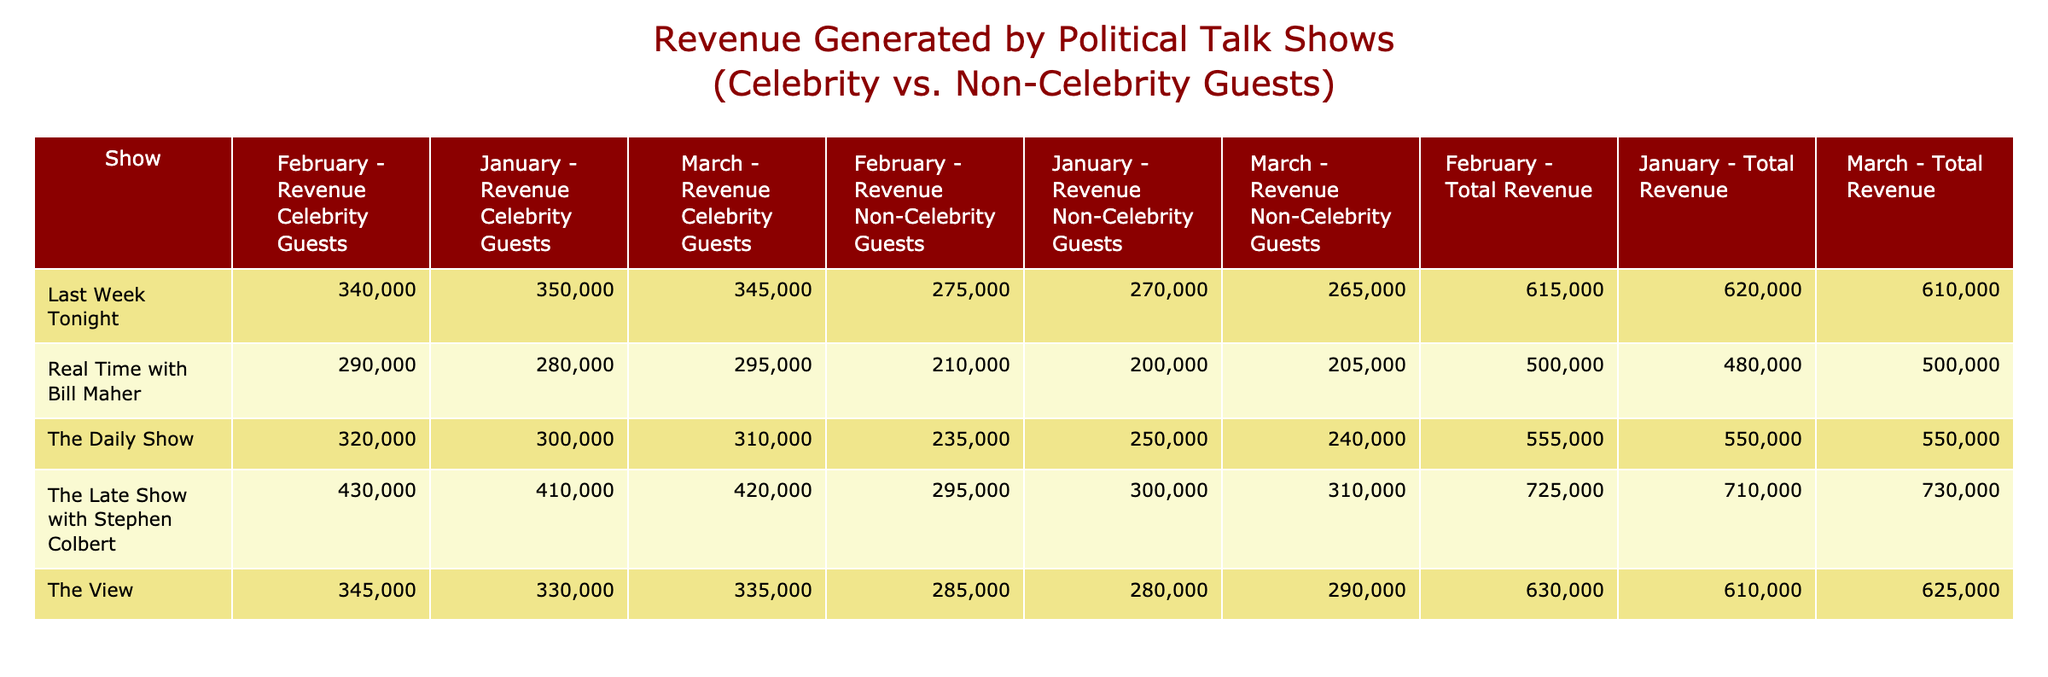What was the total revenue for The Late Show with Stephen Colbert in February? The revenue for The Late Show with Stephen Colbert in February from celebrity guests was 430,000, and from non-celebrity guests was 295,000. Adding these two amounts (430,000 + 295,000) gives us a total of 725,000.
Answer: 725000 Which show had the highest revenue from non-celebrity guests in January? In January, the non-celebrity revenue for each show was as follows: The Daily Show 250,000, Real Time with Bill Maher 200,000, Last Week Tonight 270,000, The Late Show with Stephen Colbert 300,000, and The View 280,000. The highest among these is The Late Show with Stephen Colbert at 300,000.
Answer: The Late Show with Stephen Colbert What is the average revenue generated by celebrity guests across all shows in March? The celebrity revenues in March for each show are: The Daily Show 310,000, Real Time with Bill Maher 295,000, Last Week Tonight 345,000, The Late Show with Stephen Colbert 420,000, and The View 335,000. Summing these gives 310,000 + 295,000 + 345,000 + 420,000 + 335,000 = 1,705,000. There are five shows, so dividing gives an average of 1,705,000 / 5 = 341,000.
Answer: 341000 Did The Daily Show generate more revenue from celebrity guests than Real Time with Bill Maher in February? In February, The Daily Show generated 320,000 from celebrity guests and Real Time with Bill Maher generated 290,000 from celebrity guests. Since 320,000 is greater than 290,000, the answer is yes.
Answer: Yes What was the total revenue for Last Week Tonight across all months? In January, Last Week Tonight generated 350,000, in February 340,000, and in March 345,000. Adding these three months of revenue gives 350,000 + 340,000 + 345,000 = 1,035,000.
Answer: 1035000 